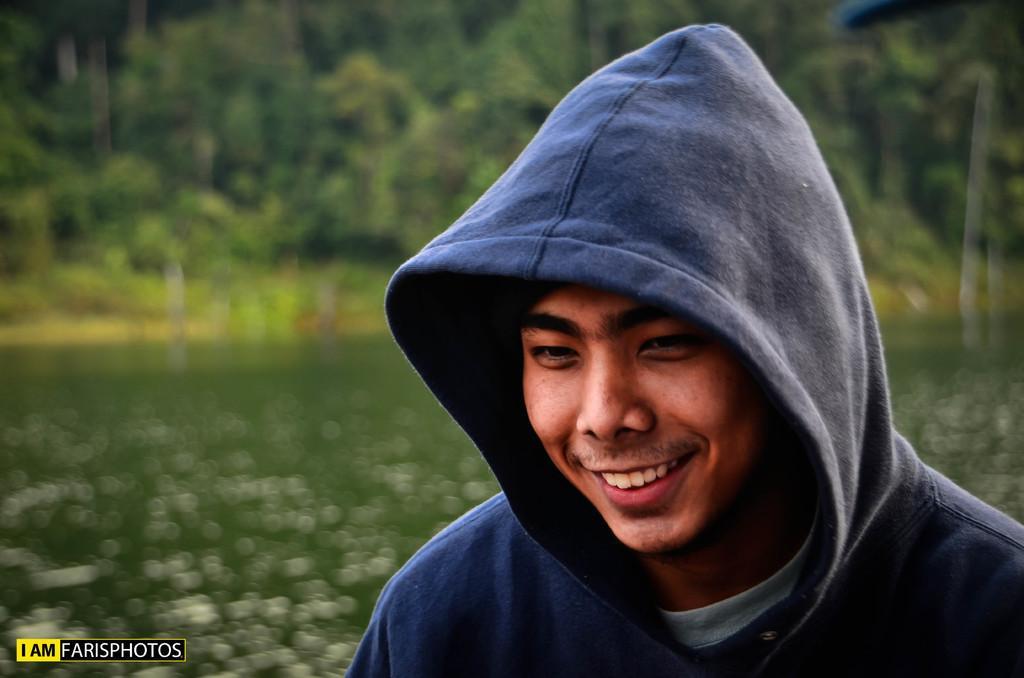Can you describe this image briefly? In this image we can see a man wearing a hoodie and smiling. In the background we can see trees and water. 